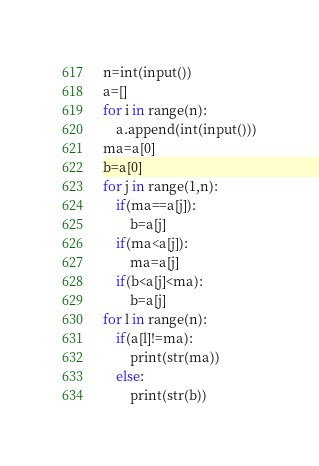Convert code to text. <code><loc_0><loc_0><loc_500><loc_500><_Python_>n=int(input())
a=[]
for i in range(n):
    a.append(int(input()))
ma=a[0]
b=a[0]
for j in range(1,n):
    if(ma==a[j]):
        b=a[j]
    if(ma<a[j]):
        ma=a[j]
    if(b<a[j]<ma):
        b=a[j]
for l in range(n):
    if(a[l]!=ma):
        print(str(ma))
    else:
        print(str(b))</code> 